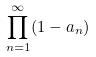<formula> <loc_0><loc_0><loc_500><loc_500>\prod _ { n = 1 } ^ { \infty } ( 1 - a _ { n } )</formula> 